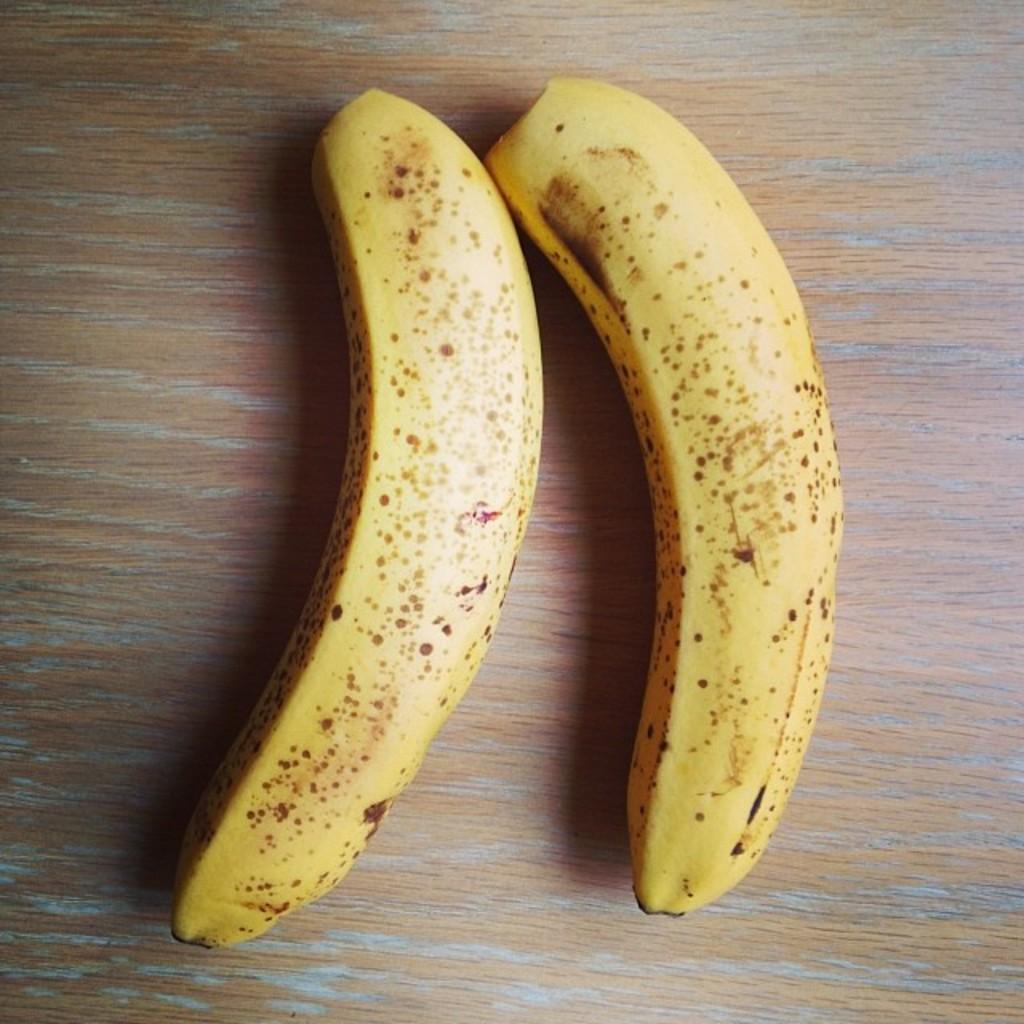What type of fruit is present in the image? There are two bananas in the image. What is the surface made of that the bananas are resting on? The bananas are on a wooden surface. What does the daughter say in the caption of the image? There is no daughter or caption present in the image. 